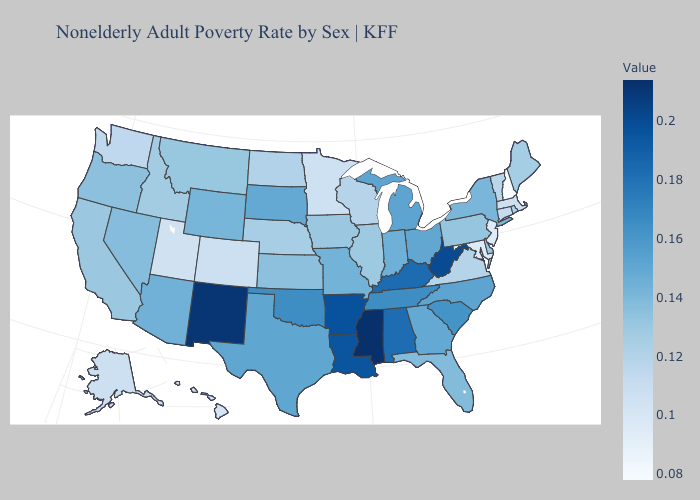Does the map have missing data?
Quick response, please. No. Does North Dakota have the highest value in the USA?
Be succinct. No. Does the map have missing data?
Keep it brief. No. Among the states that border Wyoming , which have the lowest value?
Give a very brief answer. Utah. Is the legend a continuous bar?
Keep it brief. Yes. Among the states that border Oregon , which have the highest value?
Concise answer only. Nevada. Does Maryland have the lowest value in the South?
Concise answer only. Yes. 